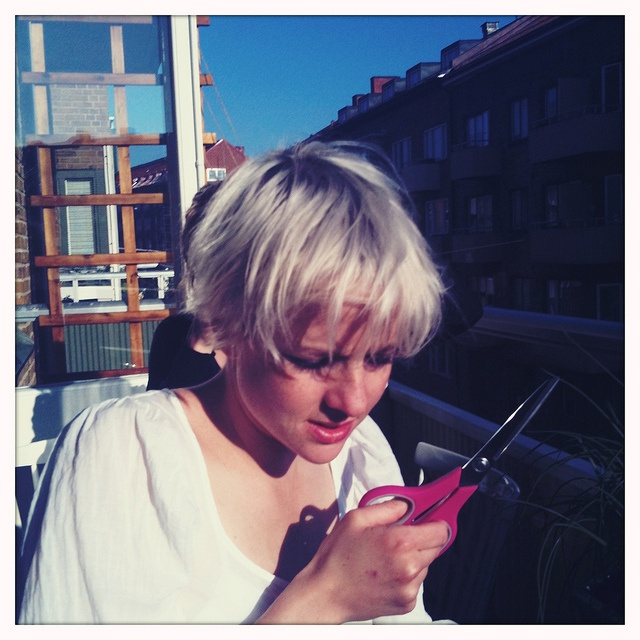Describe the objects in this image and their specific colors. I can see people in white, beige, lightpink, brown, and darkgray tones, scissors in white, black, purple, and navy tones, and people in white, black, navy, and purple tones in this image. 